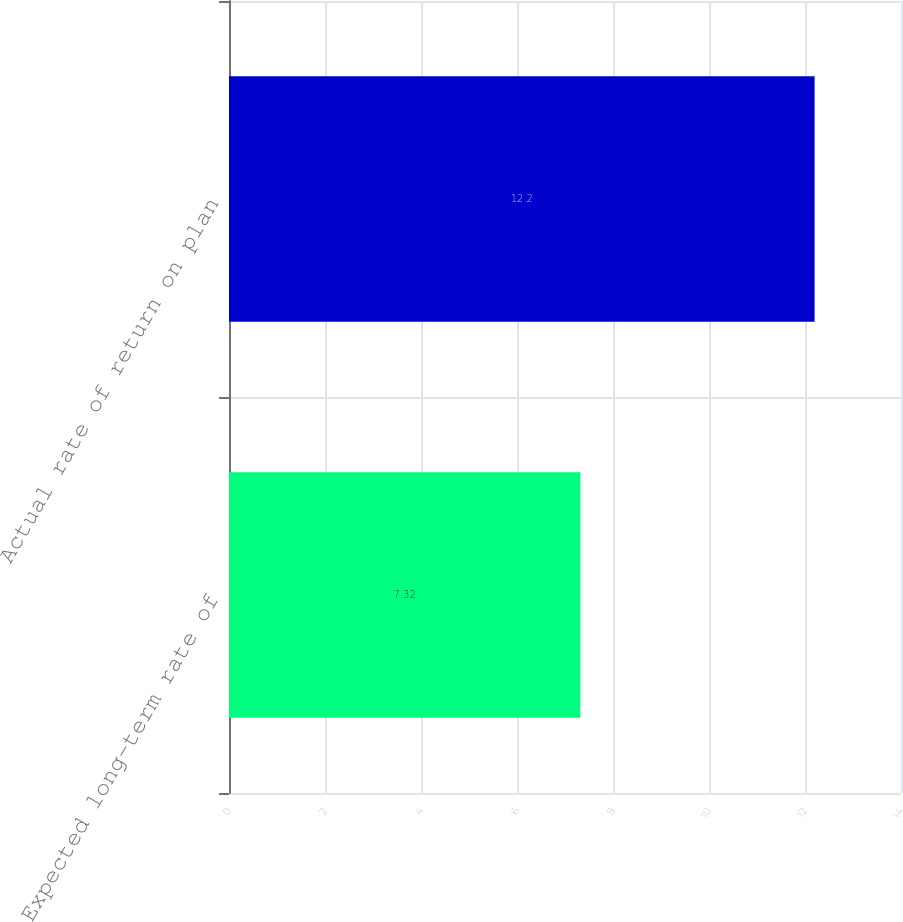Convert chart. <chart><loc_0><loc_0><loc_500><loc_500><bar_chart><fcel>Expected long-term rate of<fcel>Actual rate of return on plan<nl><fcel>7.32<fcel>12.2<nl></chart> 